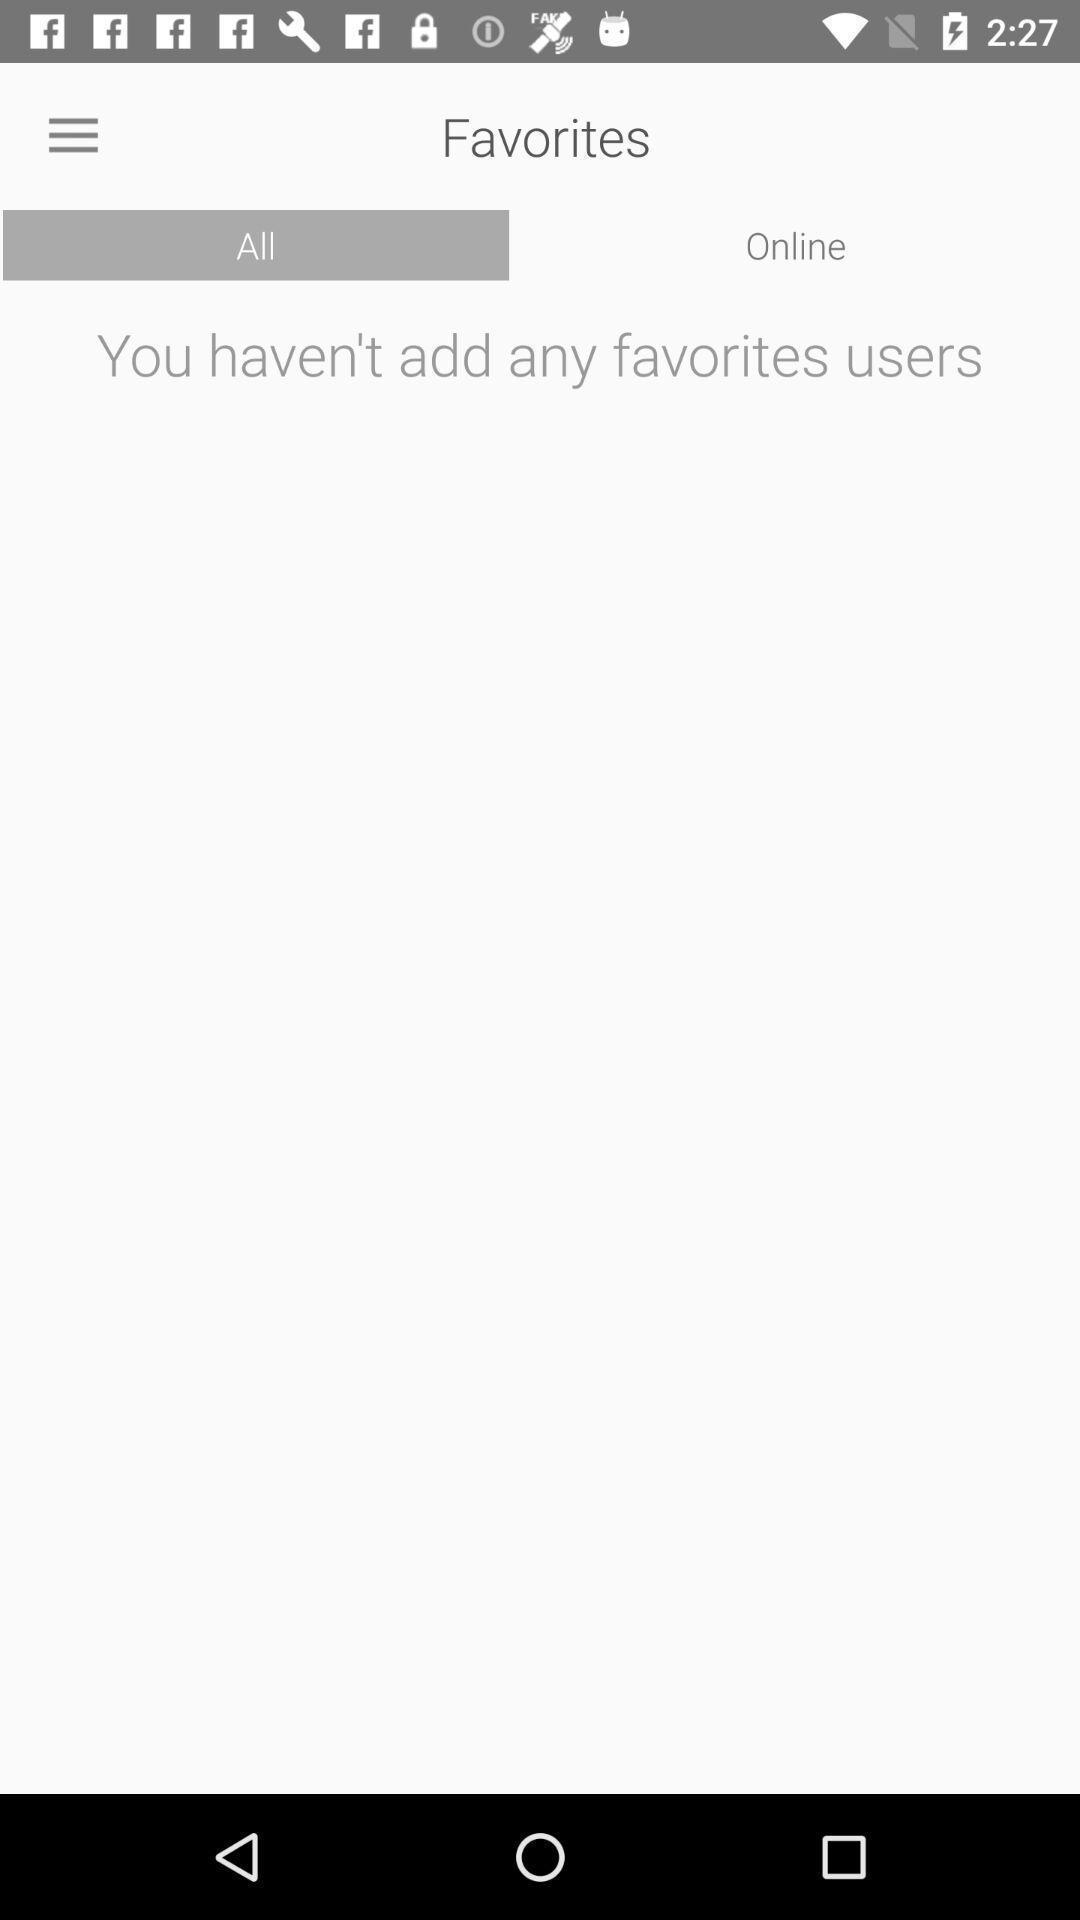Explain what's happening in this screen capture. Page displaying favorites users. 